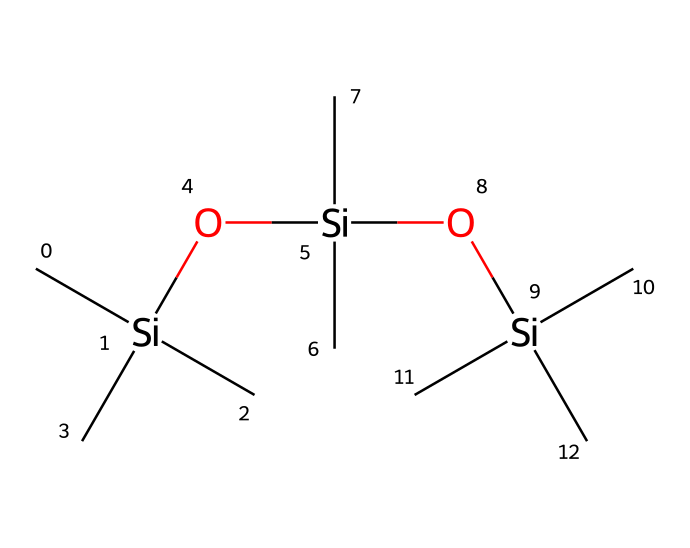how many silicon atoms are present in this chemical? The SMILES representation includes three occurrences of the element "Si" which indicates that there are three silicon atoms in total within the structure.
Answer: three how many oxygen atoms are present in this chemical? The chemical structure features two "O" representations, indicating that there are two oxygen atoms present in the compound.
Answer: two what type of chemical is this compound primarily considered? The presence of silicon and oxygen in a repeating structure suggests that this compound is classified as a siloxane, which is a common organosilicon compound.
Answer: siloxane what is the main functional group present in this chemical? The predominant feature of this structure is the siloxane bond (Si-O-Si), which indicates that the primary functional group present is the siloxane functional group.
Answer: siloxane how many carbon atoms are there in this chemical? By analyzing the SMILES, we see the "C" appears eight times, indicating the compound contains eight carbon atoms in its structure.
Answer: eight why are siloxanes effective in hair products? Siloxanes provide smoothness and shine to hair due to their unique ability to reduce surface tension and create a protective barrier, which is evident from their molecular structure that includes multiple silicon and oxygen atoms which give flexibility and hydrophobic properties.
Answer: smoothness and shine 